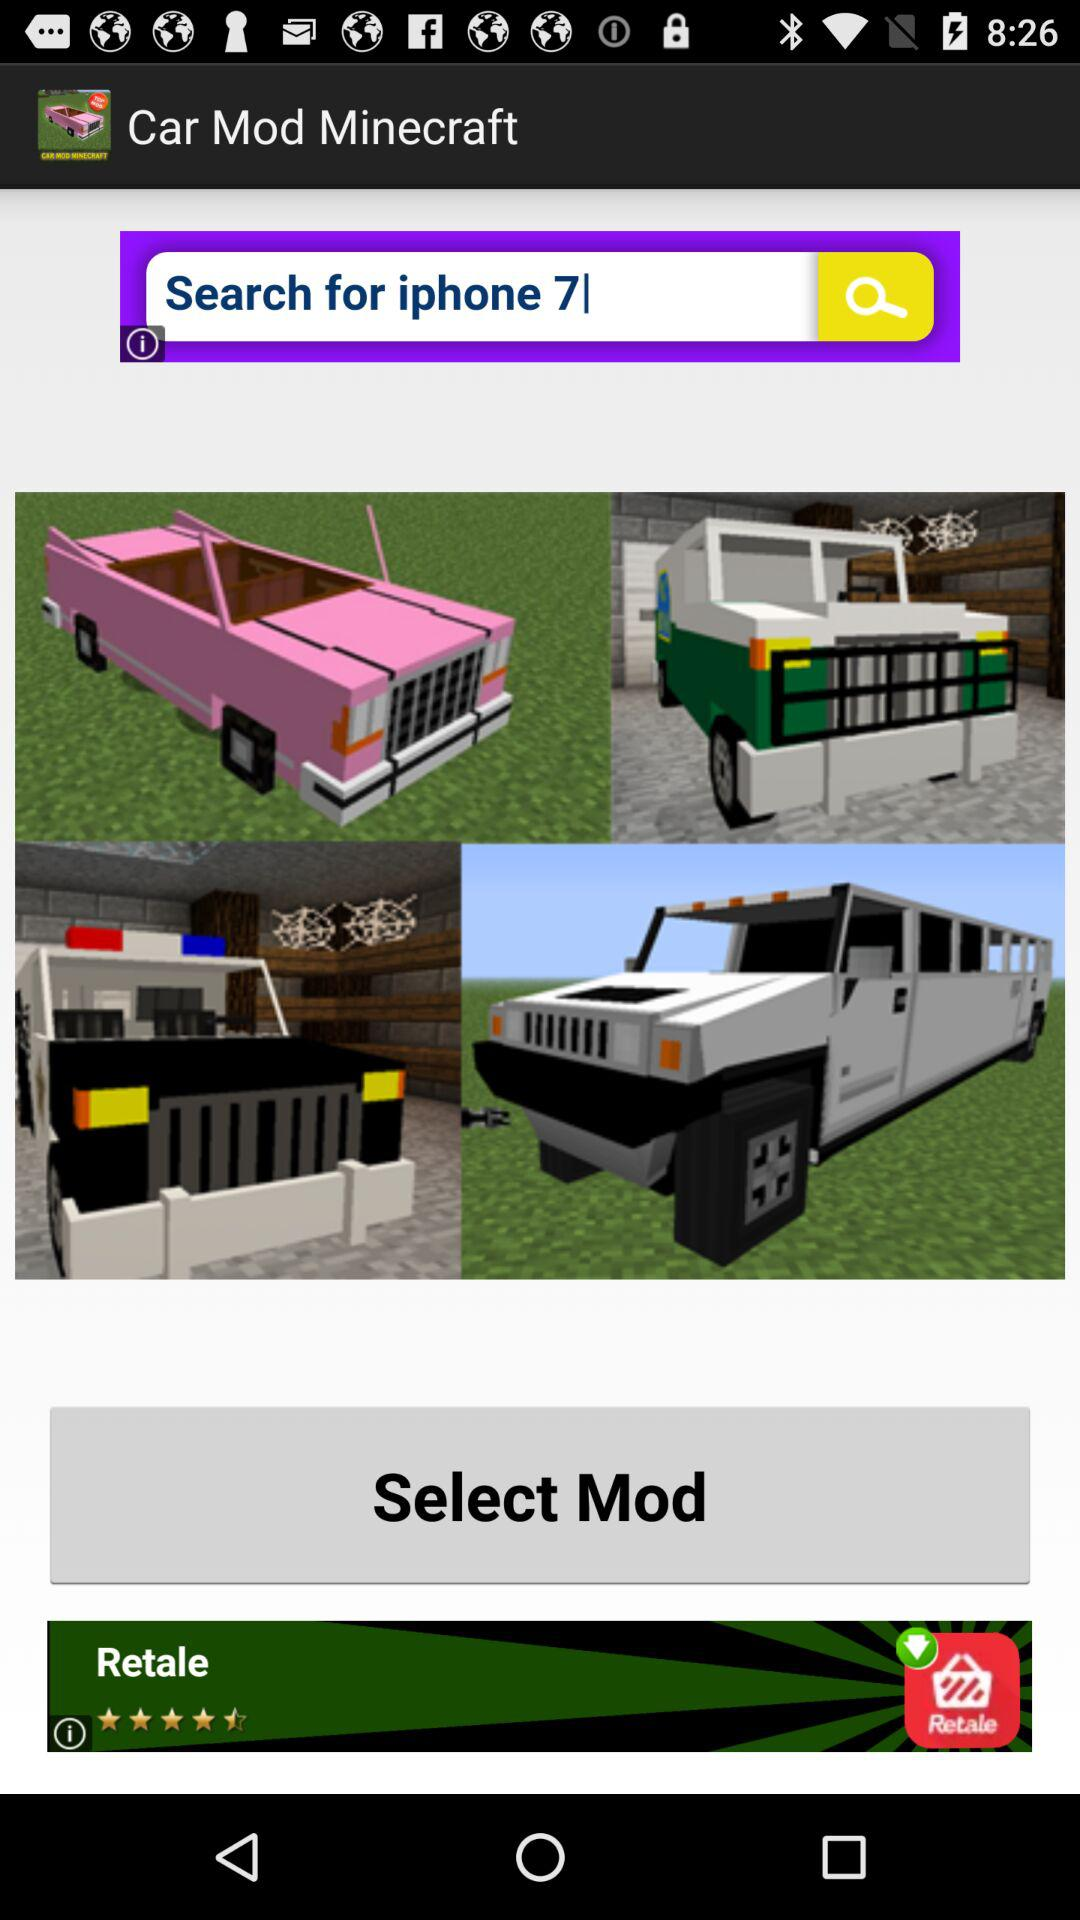How many pictures of cars are there?
Answer the question using a single word or phrase. 4 